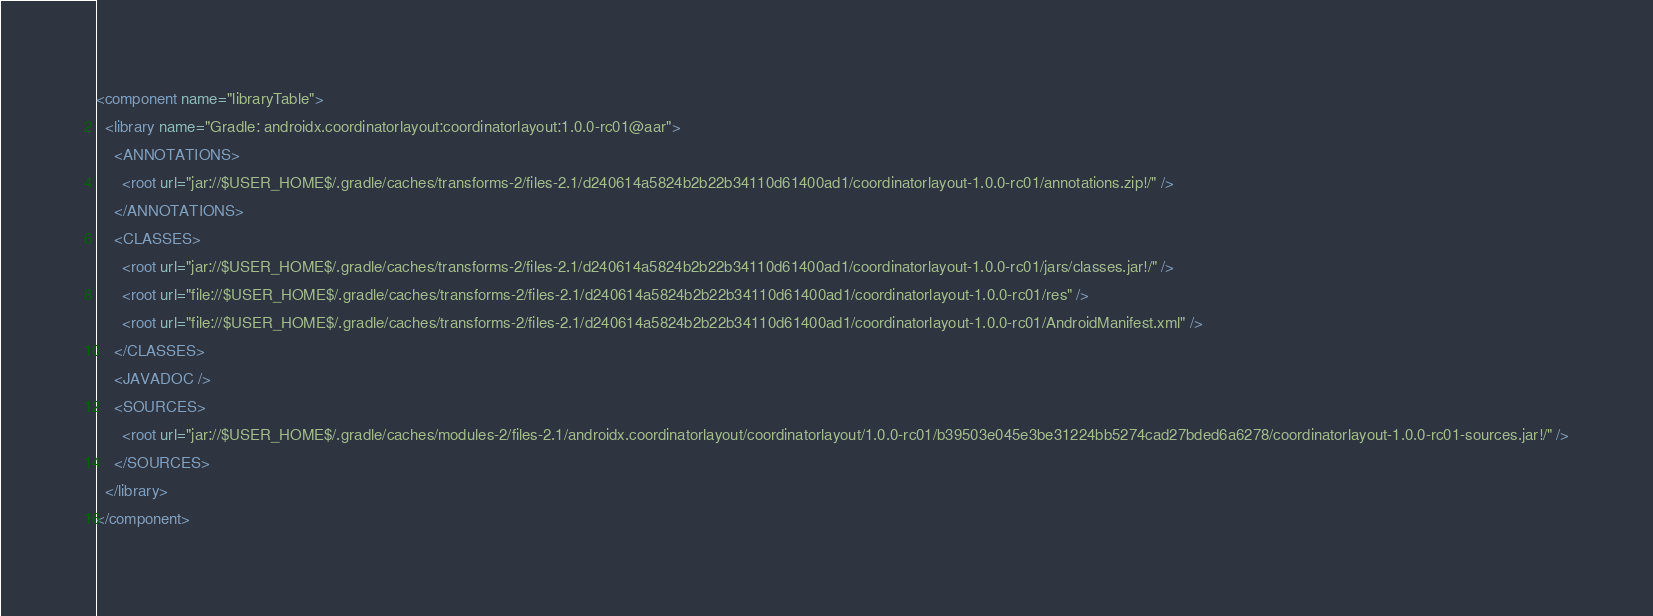<code> <loc_0><loc_0><loc_500><loc_500><_XML_><component name="libraryTable">
  <library name="Gradle: androidx.coordinatorlayout:coordinatorlayout:1.0.0-rc01@aar">
    <ANNOTATIONS>
      <root url="jar://$USER_HOME$/.gradle/caches/transforms-2/files-2.1/d240614a5824b2b22b34110d61400ad1/coordinatorlayout-1.0.0-rc01/annotations.zip!/" />
    </ANNOTATIONS>
    <CLASSES>
      <root url="jar://$USER_HOME$/.gradle/caches/transforms-2/files-2.1/d240614a5824b2b22b34110d61400ad1/coordinatorlayout-1.0.0-rc01/jars/classes.jar!/" />
      <root url="file://$USER_HOME$/.gradle/caches/transforms-2/files-2.1/d240614a5824b2b22b34110d61400ad1/coordinatorlayout-1.0.0-rc01/res" />
      <root url="file://$USER_HOME$/.gradle/caches/transforms-2/files-2.1/d240614a5824b2b22b34110d61400ad1/coordinatorlayout-1.0.0-rc01/AndroidManifest.xml" />
    </CLASSES>
    <JAVADOC />
    <SOURCES>
      <root url="jar://$USER_HOME$/.gradle/caches/modules-2/files-2.1/androidx.coordinatorlayout/coordinatorlayout/1.0.0-rc01/b39503e045e3be31224bb5274cad27bded6a6278/coordinatorlayout-1.0.0-rc01-sources.jar!/" />
    </SOURCES>
  </library>
</component></code> 